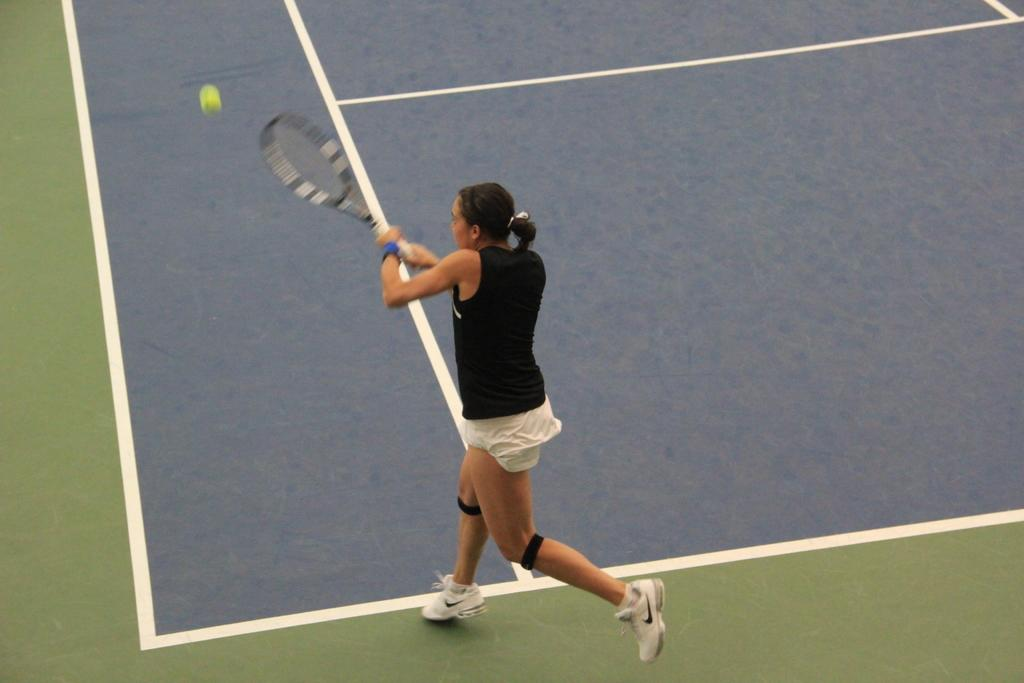Who is present in the image? There is a woman in the image. What is the woman doing in the image? The woman is on the ground and holding a racket with her hands. What else can be seen in the image? There is a ball in the image. How many dolls are sitting on the coach in the image? There are no dolls or coaches present in the image. 